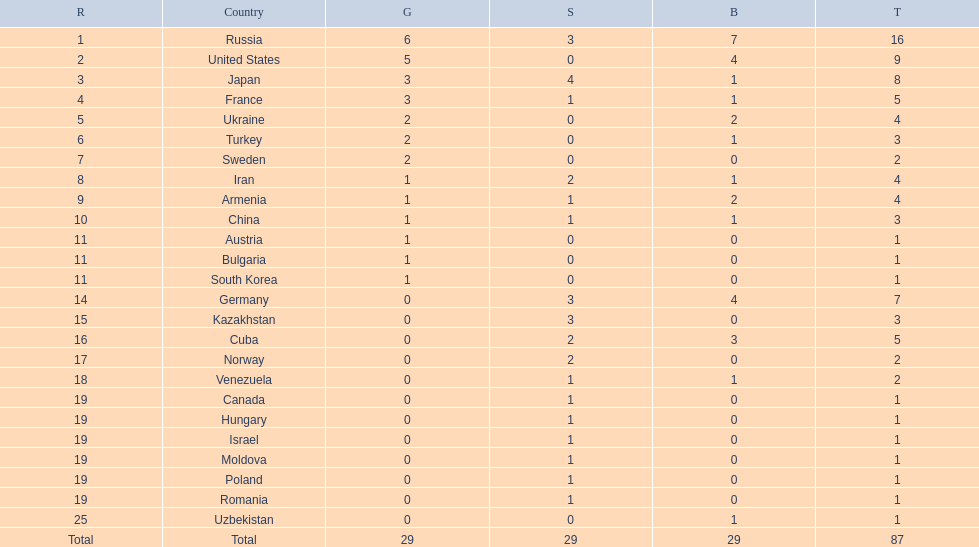Which nations participated in the championships? Russia, United States, Japan, France, Ukraine, Turkey, Sweden, Iran, Armenia, China, Austria, Bulgaria, South Korea, Germany, Kazakhstan, Cuba, Norway, Venezuela, Canada, Hungary, Israel, Moldova, Poland, Romania, Uzbekistan. How many bronze medals did they receive? 7, 4, 1, 1, 2, 1, 0, 1, 2, 1, 0, 0, 0, 4, 0, 3, 0, 1, 0, 0, 0, 0, 0, 0, 1, 29. How many in total? 16, 9, 8, 5, 4, 3, 2, 4, 4, 3, 1, 1, 1, 7, 3, 5, 2, 2, 1, 1, 1, 1, 1, 1, 1. And which team won only one medal -- the bronze? Uzbekistan. 